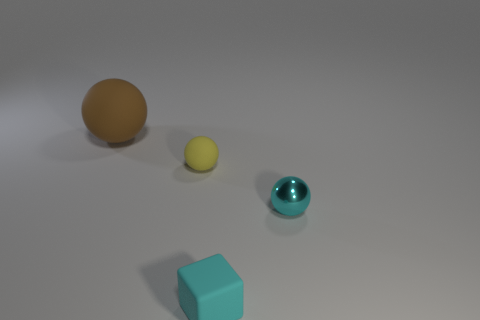Subtract all tiny spheres. How many spheres are left? 1 Subtract 1 spheres. How many spheres are left? 2 Add 1 cubes. How many objects exist? 5 Subtract all blue blocks. Subtract all yellow spheres. How many blocks are left? 1 Subtract all cubes. How many objects are left? 3 Subtract all tiny cyan rubber objects. Subtract all big brown matte objects. How many objects are left? 2 Add 2 tiny rubber spheres. How many tiny rubber spheres are left? 3 Add 1 large brown things. How many large brown things exist? 2 Subtract 0 blue cylinders. How many objects are left? 4 